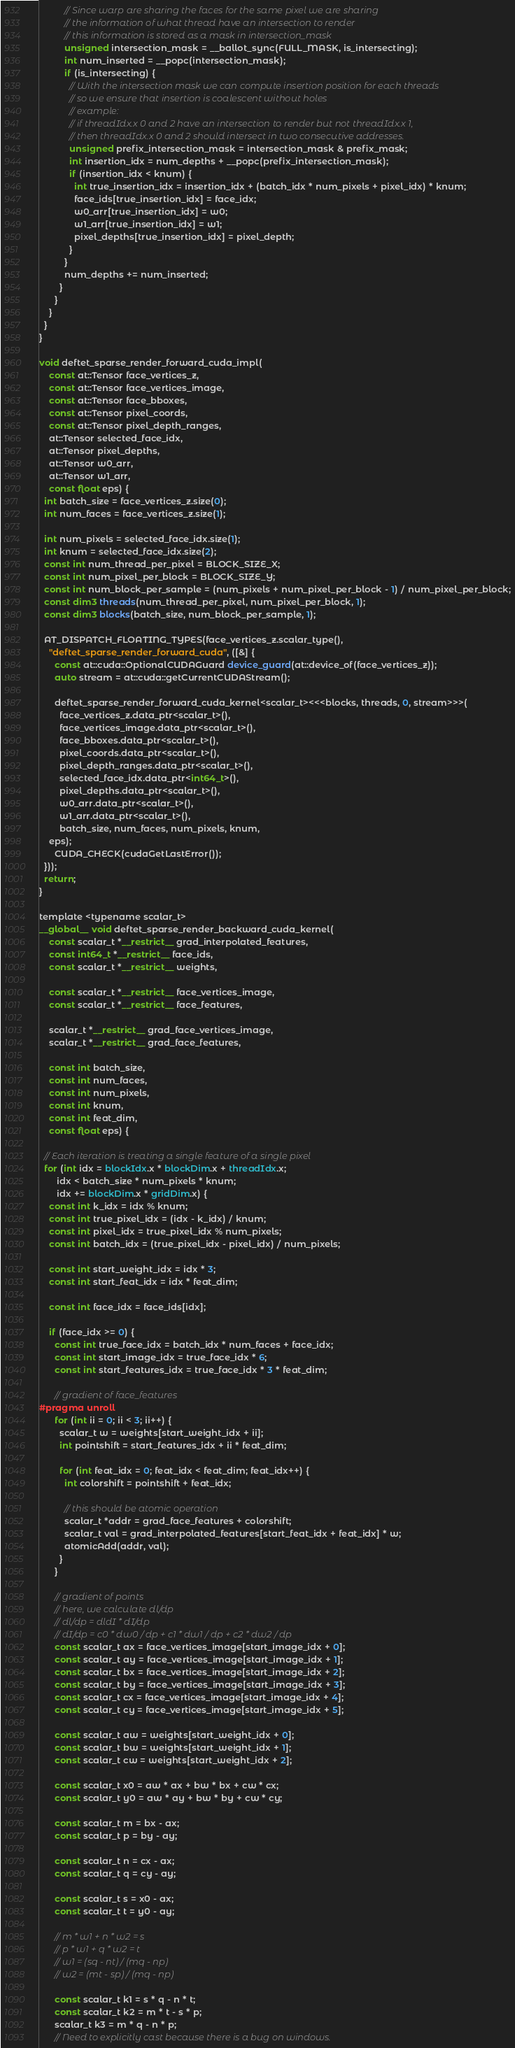Convert code to text. <code><loc_0><loc_0><loc_500><loc_500><_Cuda_>          // Since warp are sharing the faces for the same pixel we are sharing
          // the information of what thread have an intersection to render
          // this information is stored as a mask in intersection_mask
          unsigned intersection_mask = __ballot_sync(FULL_MASK, is_intersecting);
          int num_inserted = __popc(intersection_mask);
          if (is_intersecting) {
            // With the intersection mask we can compute insertion position for each threads
            // so we ensure that insertion is coalescent without holes
            // example:
            // if threadIdx.x 0 and 2 have an intersection to render but not threadIdx.x 1,
            // then threadIdx.x 0 and 2 should intersect in two consecutive addresses.
            unsigned prefix_intersection_mask = intersection_mask & prefix_mask;
            int insertion_idx = num_depths + __popc(prefix_intersection_mask);
            if (insertion_idx < knum) {
              int true_insertion_idx = insertion_idx + (batch_idx * num_pixels + pixel_idx) * knum;
              face_ids[true_insertion_idx] = face_idx;
              w0_arr[true_insertion_idx] = w0;
              w1_arr[true_insertion_idx] = w1;
              pixel_depths[true_insertion_idx] = pixel_depth;
            }
          }
          num_depths += num_inserted;
        }
      }
    }
  }
}

void deftet_sparse_render_forward_cuda_impl(
    const at::Tensor face_vertices_z,
    const at::Tensor face_vertices_image,
    const at::Tensor face_bboxes,
    const at::Tensor pixel_coords,
    const at::Tensor pixel_depth_ranges,
    at::Tensor selected_face_idx,
    at::Tensor pixel_depths,
    at::Tensor w0_arr,
    at::Tensor w1_arr,
    const float eps) {
  int batch_size = face_vertices_z.size(0);
  int num_faces = face_vertices_z.size(1);

  int num_pixels = selected_face_idx.size(1);
  int knum = selected_face_idx.size(2);
  const int num_thread_per_pixel = BLOCK_SIZE_X;
  const int num_pixel_per_block = BLOCK_SIZE_Y;
  const int num_block_per_sample = (num_pixels + num_pixel_per_block - 1) / num_pixel_per_block;
  const dim3 threads(num_thread_per_pixel, num_pixel_per_block, 1);
  const dim3 blocks(batch_size, num_block_per_sample, 1);

  AT_DISPATCH_FLOATING_TYPES(face_vertices_z.scalar_type(),
    "deftet_sparse_render_forward_cuda", ([&] {
      const at::cuda::OptionalCUDAGuard device_guard(at::device_of(face_vertices_z));
      auto stream = at::cuda::getCurrentCUDAStream();

      deftet_sparse_render_forward_cuda_kernel<scalar_t><<<blocks, threads, 0, stream>>>(
        face_vertices_z.data_ptr<scalar_t>(),
        face_vertices_image.data_ptr<scalar_t>(),
        face_bboxes.data_ptr<scalar_t>(),
        pixel_coords.data_ptr<scalar_t>(),
        pixel_depth_ranges.data_ptr<scalar_t>(),
        selected_face_idx.data_ptr<int64_t>(),
        pixel_depths.data_ptr<scalar_t>(),
        w0_arr.data_ptr<scalar_t>(),
        w1_arr.data_ptr<scalar_t>(),
        batch_size, num_faces, num_pixels, knum,
	eps);
      CUDA_CHECK(cudaGetLastError());
  }));
  return;
}

template <typename scalar_t>
__global__ void deftet_sparse_render_backward_cuda_kernel(
    const scalar_t *__restrict__ grad_interpolated_features,
    const int64_t *__restrict__ face_ids,
    const scalar_t *__restrict__ weights,

    const scalar_t *__restrict__ face_vertices_image,
    const scalar_t *__restrict__ face_features,

    scalar_t *__restrict__ grad_face_vertices_image,
    scalar_t *__restrict__ grad_face_features,

    const int batch_size,
    const int num_faces,
    const int num_pixels,
    const int knum,
    const int feat_dim,
    const float eps) {

  // Each iteration is treating a single feature of a single pixel
  for (int idx = blockIdx.x * blockDim.x + threadIdx.x;
       idx < batch_size * num_pixels * knum;
       idx += blockDim.x * gridDim.x) {
    const int k_idx = idx % knum;
    const int true_pixel_idx = (idx - k_idx) / knum;
    const int pixel_idx = true_pixel_idx % num_pixels;
    const int batch_idx = (true_pixel_idx - pixel_idx) / num_pixels;

    const int start_weight_idx = idx * 3;
    const int start_feat_idx = idx * feat_dim;

    const int face_idx = face_ids[idx];

    if (face_idx >= 0) {
      const int true_face_idx = batch_idx * num_faces + face_idx;
      const int start_image_idx = true_face_idx * 6;
      const int start_features_idx = true_face_idx * 3 * feat_dim;

      // gradient of face_features
#pragma unroll
      for (int ii = 0; ii < 3; ii++) {
        scalar_t w = weights[start_weight_idx + ii];
        int pointshift = start_features_idx + ii * feat_dim;

        for (int feat_idx = 0; feat_idx < feat_dim; feat_idx++) {
          int colorshift = pointshift + feat_idx;

          // this should be atomic operation
          scalar_t *addr = grad_face_features + colorshift;
          scalar_t val = grad_interpolated_features[start_feat_idx + feat_idx] * w;
          atomicAdd(addr, val);
        }
      }

      // gradient of points
      // here, we calculate dl/dp
      // dl/dp = dldI * dI/dp
      // dI/dp = c0 * dw0 / dp + c1 * dw1 / dp + c2 * dw2 / dp
      const scalar_t ax = face_vertices_image[start_image_idx + 0];
      const scalar_t ay = face_vertices_image[start_image_idx + 1];
      const scalar_t bx = face_vertices_image[start_image_idx + 2];
      const scalar_t by = face_vertices_image[start_image_idx + 3];
      const scalar_t cx = face_vertices_image[start_image_idx + 4];
      const scalar_t cy = face_vertices_image[start_image_idx + 5];

      const scalar_t aw = weights[start_weight_idx + 0];
      const scalar_t bw = weights[start_weight_idx + 1];
      const scalar_t cw = weights[start_weight_idx + 2];

      const scalar_t x0 = aw * ax + bw * bx + cw * cx;
      const scalar_t y0 = aw * ay + bw * by + cw * cy;

      const scalar_t m = bx - ax;
      const scalar_t p = by - ay;

      const scalar_t n = cx - ax;
      const scalar_t q = cy - ay;

      const scalar_t s = x0 - ax;
      const scalar_t t = y0 - ay;

      // m * w1 + n * w2 = s
      // p * w1 + q * w2 = t
      // w1 = (sq - nt) / (mq - np)
      // w2 = (mt - sp) / (mq - np)

      const scalar_t k1 = s * q - n * t;
      const scalar_t k2 = m * t - s * p;
      scalar_t k3 = m * q - n * p;
      // Need to explicitly cast because there is a bug on windows.</code> 